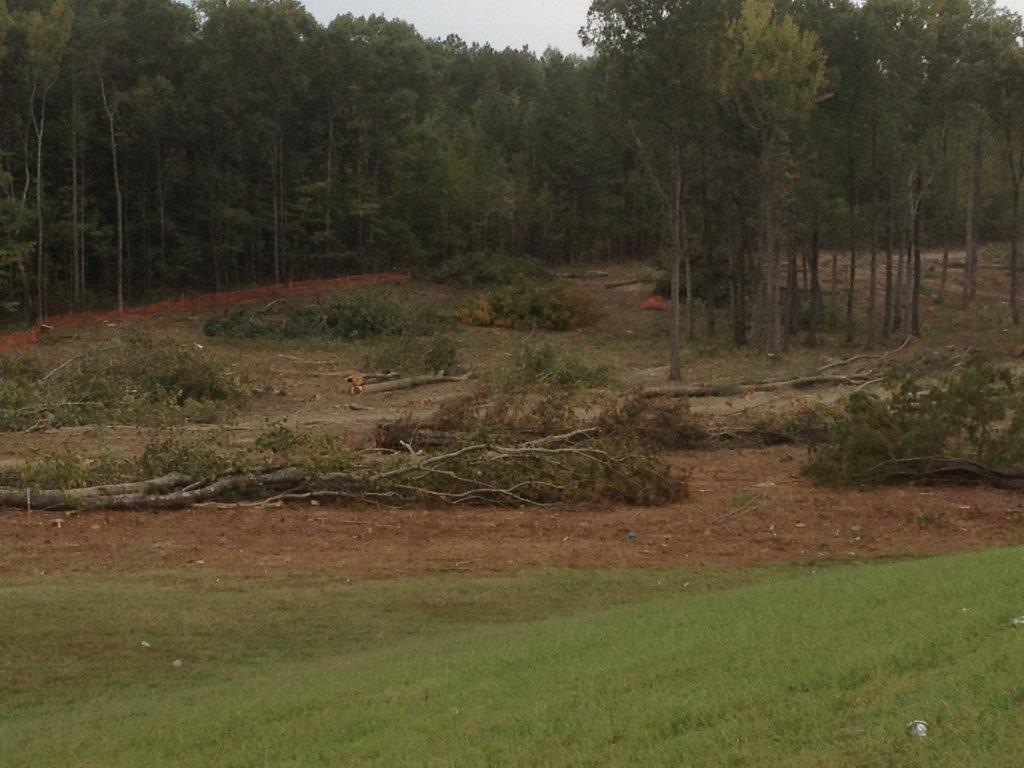How would you summarize this image in a sentence or two? In the center of the image we can see the sky, trees, plants, grass and soil. 